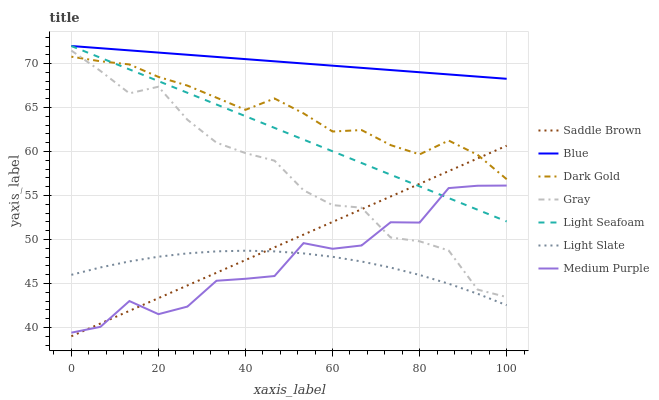Does Gray have the minimum area under the curve?
Answer yes or no. No. Does Gray have the maximum area under the curve?
Answer yes or no. No. Is Gray the smoothest?
Answer yes or no. No. Is Gray the roughest?
Answer yes or no. No. Does Gray have the lowest value?
Answer yes or no. No. Does Gray have the highest value?
Answer yes or no. No. Is Gray less than Light Seafoam?
Answer yes or no. Yes. Is Dark Gold greater than Light Slate?
Answer yes or no. Yes. Does Gray intersect Light Seafoam?
Answer yes or no. No. 